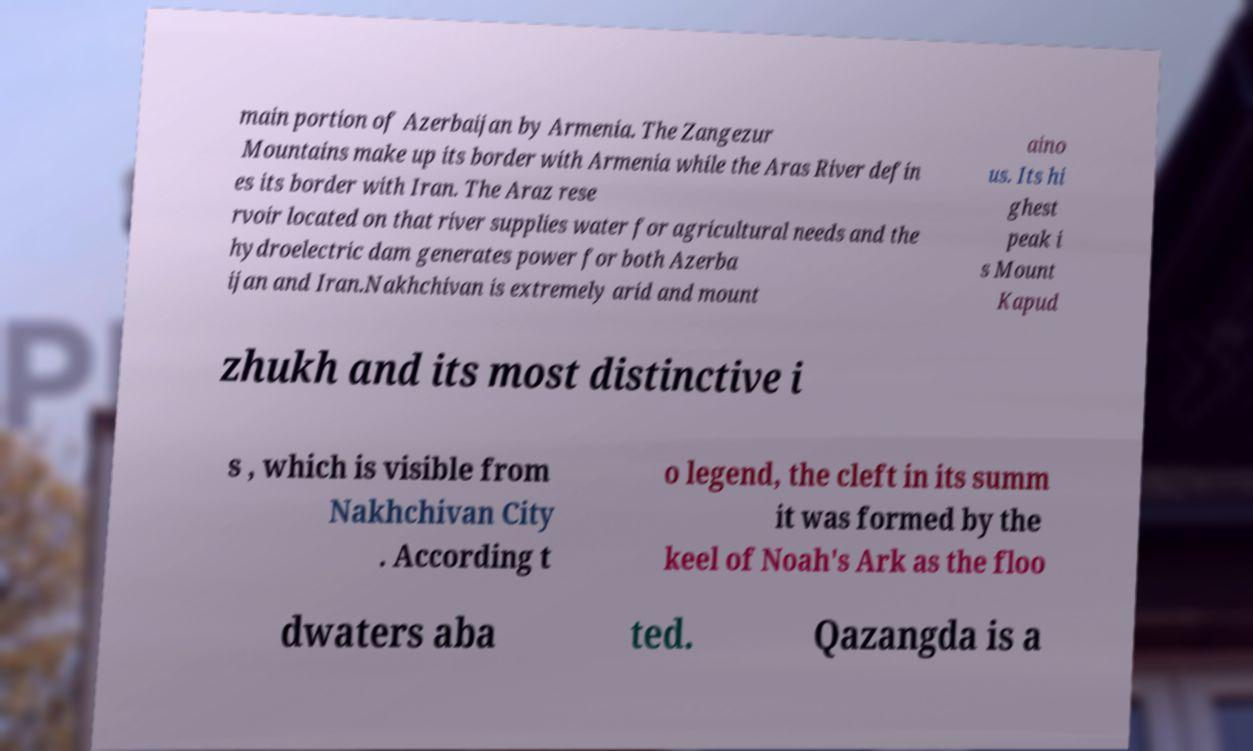Please read and relay the text visible in this image. What does it say? main portion of Azerbaijan by Armenia. The Zangezur Mountains make up its border with Armenia while the Aras River defin es its border with Iran. The Araz rese rvoir located on that river supplies water for agricultural needs and the hydroelectric dam generates power for both Azerba ijan and Iran.Nakhchivan is extremely arid and mount aino us. Its hi ghest peak i s Mount Kapud zhukh and its most distinctive i s , which is visible from Nakhchivan City . According t o legend, the cleft in its summ it was formed by the keel of Noah's Ark as the floo dwaters aba ted. Qazangda is a 